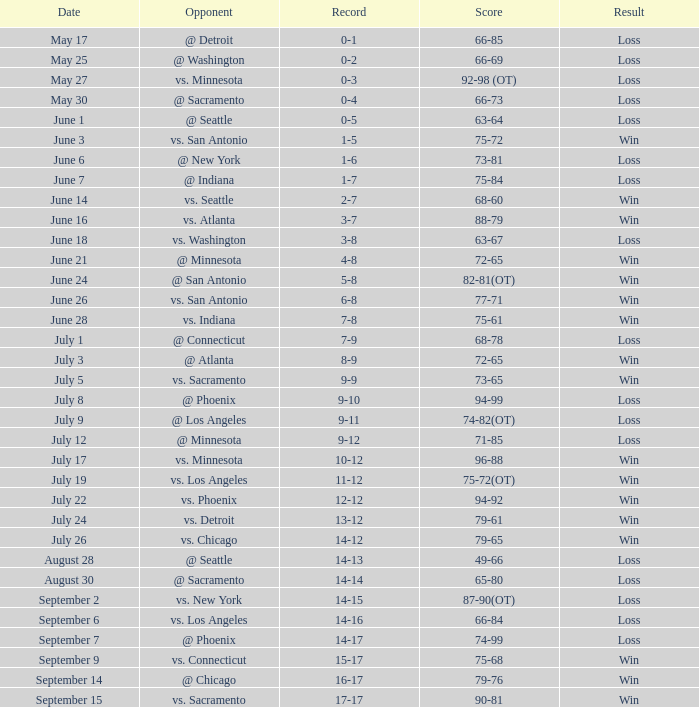What was the Result on July 24? Win. 